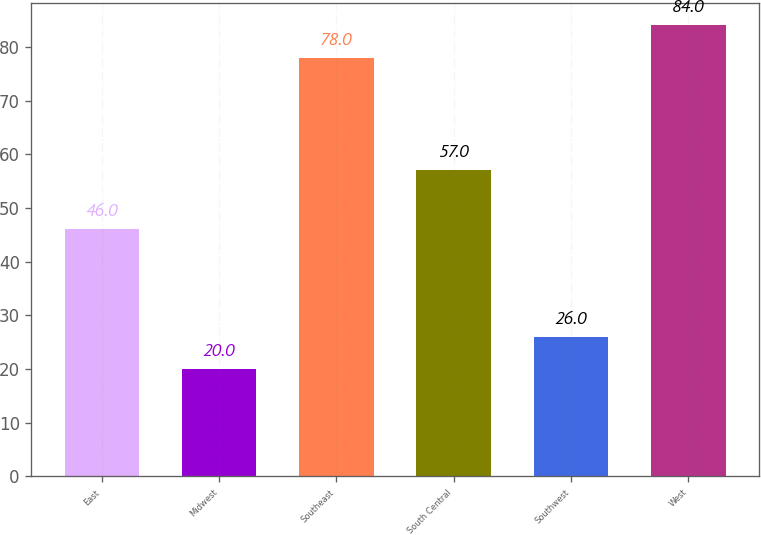<chart> <loc_0><loc_0><loc_500><loc_500><bar_chart><fcel>East<fcel>Midwest<fcel>Southeast<fcel>South Central<fcel>Southwest<fcel>West<nl><fcel>46<fcel>20<fcel>78<fcel>57<fcel>26<fcel>84<nl></chart> 